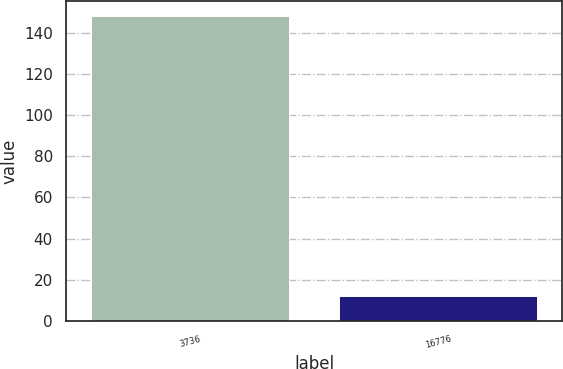Convert chart to OTSL. <chart><loc_0><loc_0><loc_500><loc_500><bar_chart><fcel>3736<fcel>16776<nl><fcel>148<fcel>12<nl></chart> 